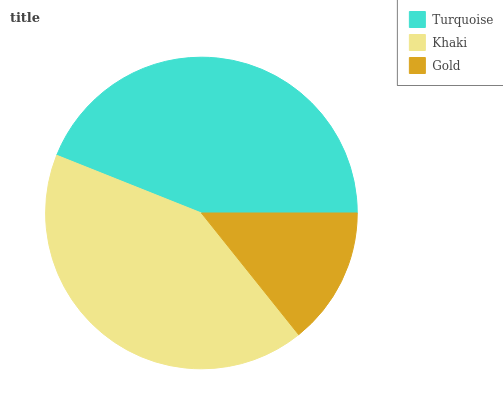Is Gold the minimum?
Answer yes or no. Yes. Is Turquoise the maximum?
Answer yes or no. Yes. Is Khaki the minimum?
Answer yes or no. No. Is Khaki the maximum?
Answer yes or no. No. Is Turquoise greater than Khaki?
Answer yes or no. Yes. Is Khaki less than Turquoise?
Answer yes or no. Yes. Is Khaki greater than Turquoise?
Answer yes or no. No. Is Turquoise less than Khaki?
Answer yes or no. No. Is Khaki the high median?
Answer yes or no. Yes. Is Khaki the low median?
Answer yes or no. Yes. Is Gold the high median?
Answer yes or no. No. Is Gold the low median?
Answer yes or no. No. 